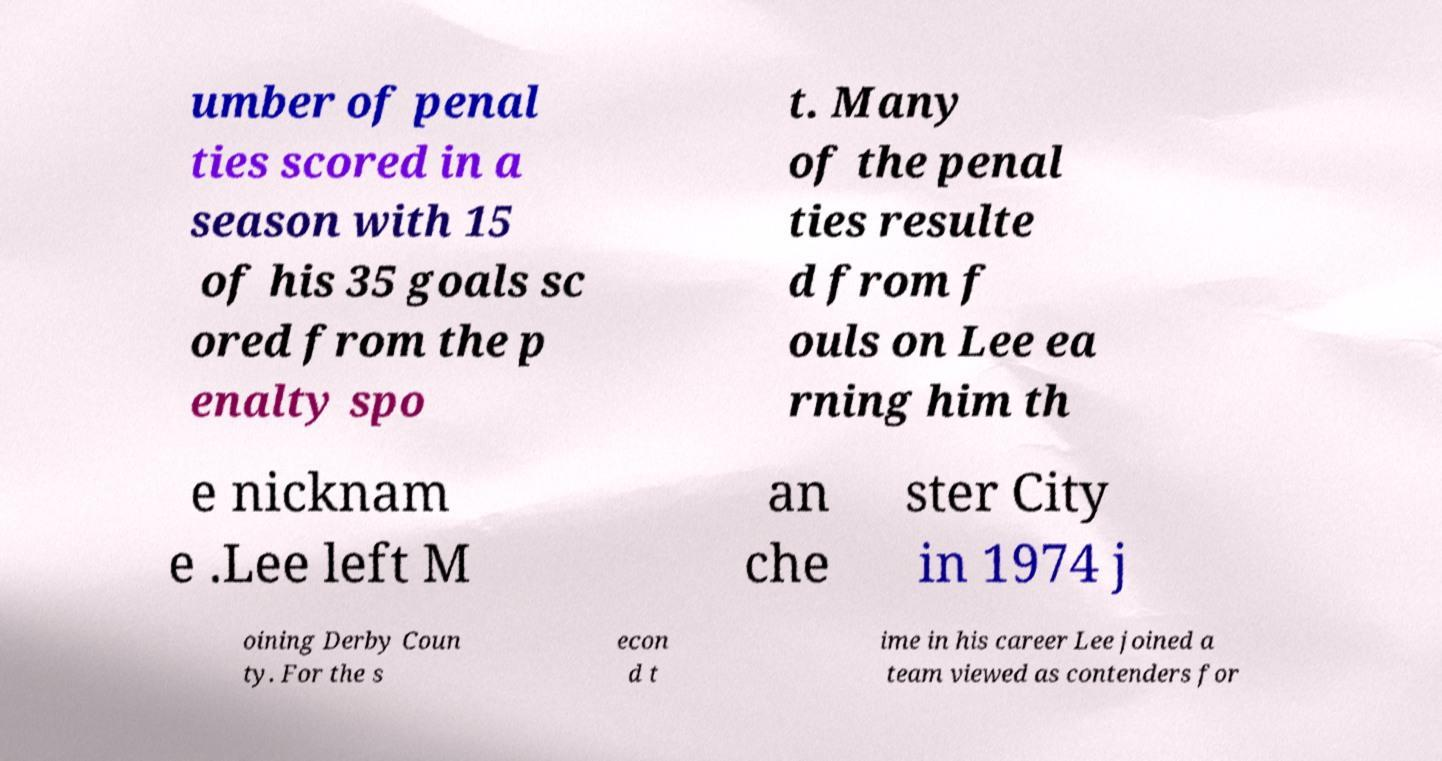Please identify and transcribe the text found in this image. umber of penal ties scored in a season with 15 of his 35 goals sc ored from the p enalty spo t. Many of the penal ties resulte d from f ouls on Lee ea rning him th e nicknam e .Lee left M an che ster City in 1974 j oining Derby Coun ty. For the s econ d t ime in his career Lee joined a team viewed as contenders for 